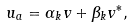<formula> <loc_0><loc_0><loc_500><loc_500>u _ { a } = \alpha _ { k } v + \beta _ { k } v ^ { * } ,</formula> 